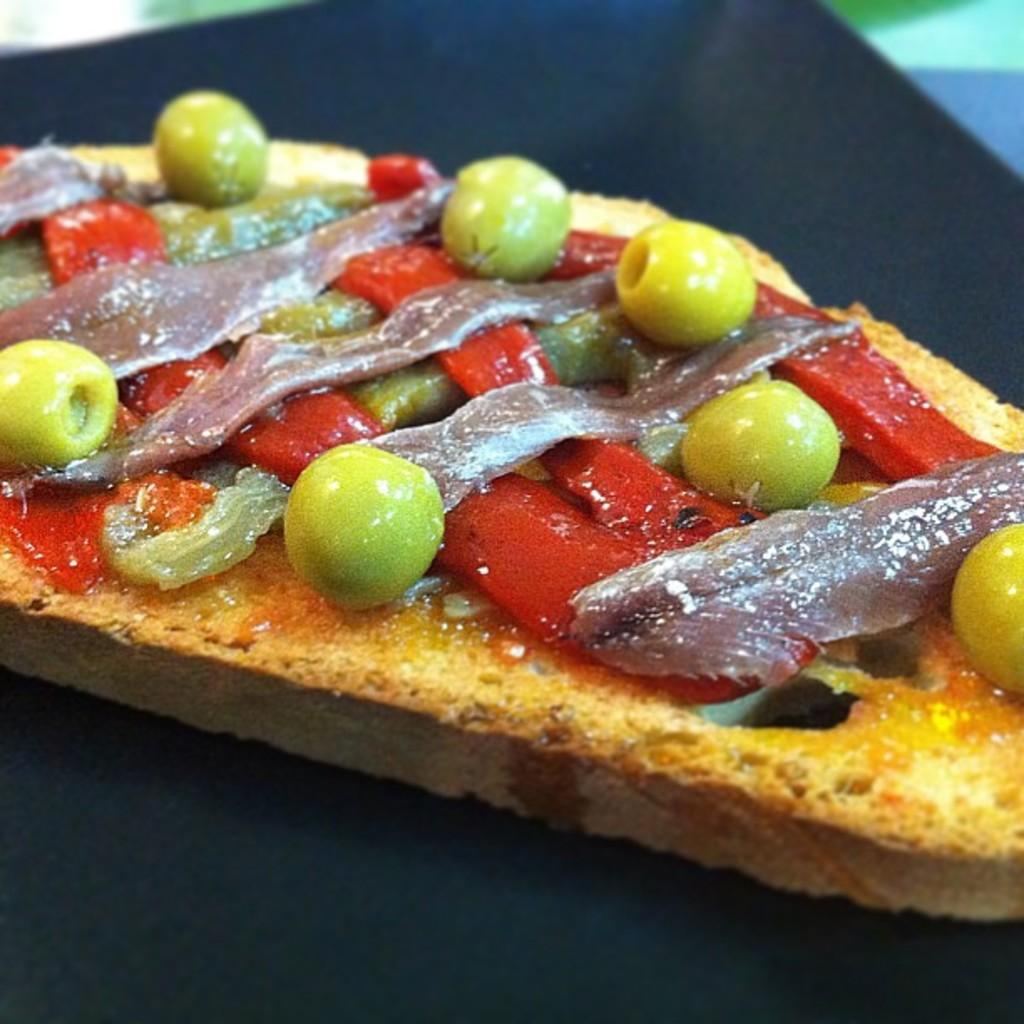What types of items can be seen in the image? There are food items in the image. What is the color of the surface on which the food items are placed? The surface is black in color. What type of clouds can be seen in the image? There are no clouds present in the image; it features food items on a black surface. What part of the food items is ornamented with a decorative design? There is no information about any ornamentation or decorative design on the food items in the image. 